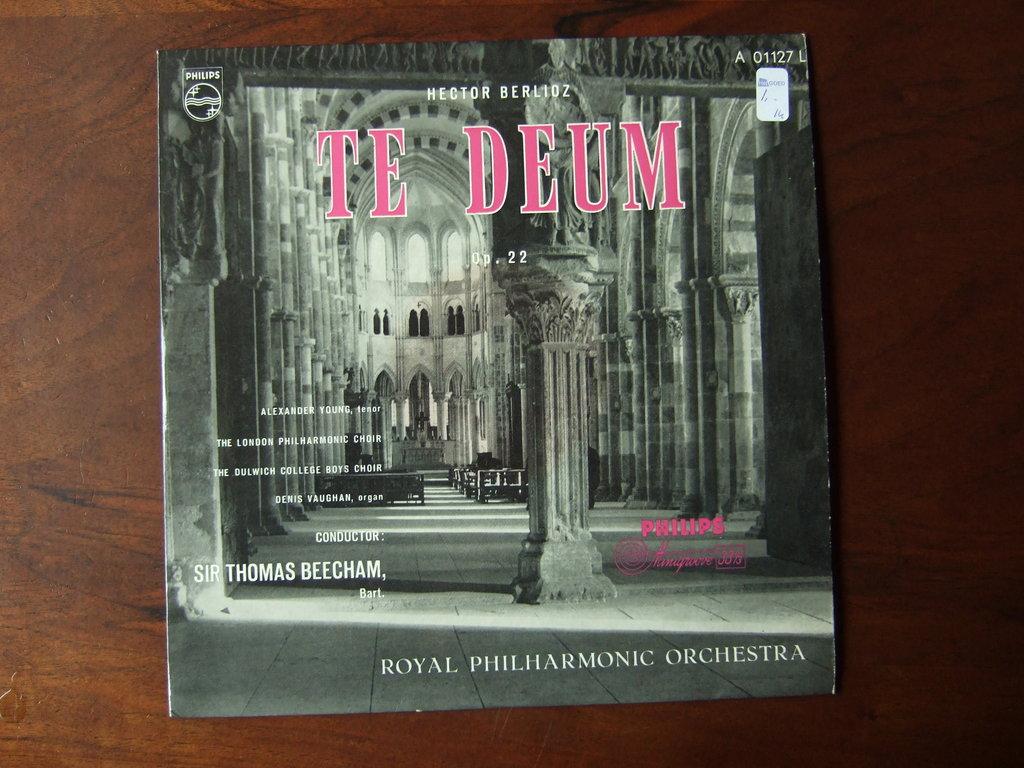Who is the artist?
Your answer should be compact. Hector berlioz. 